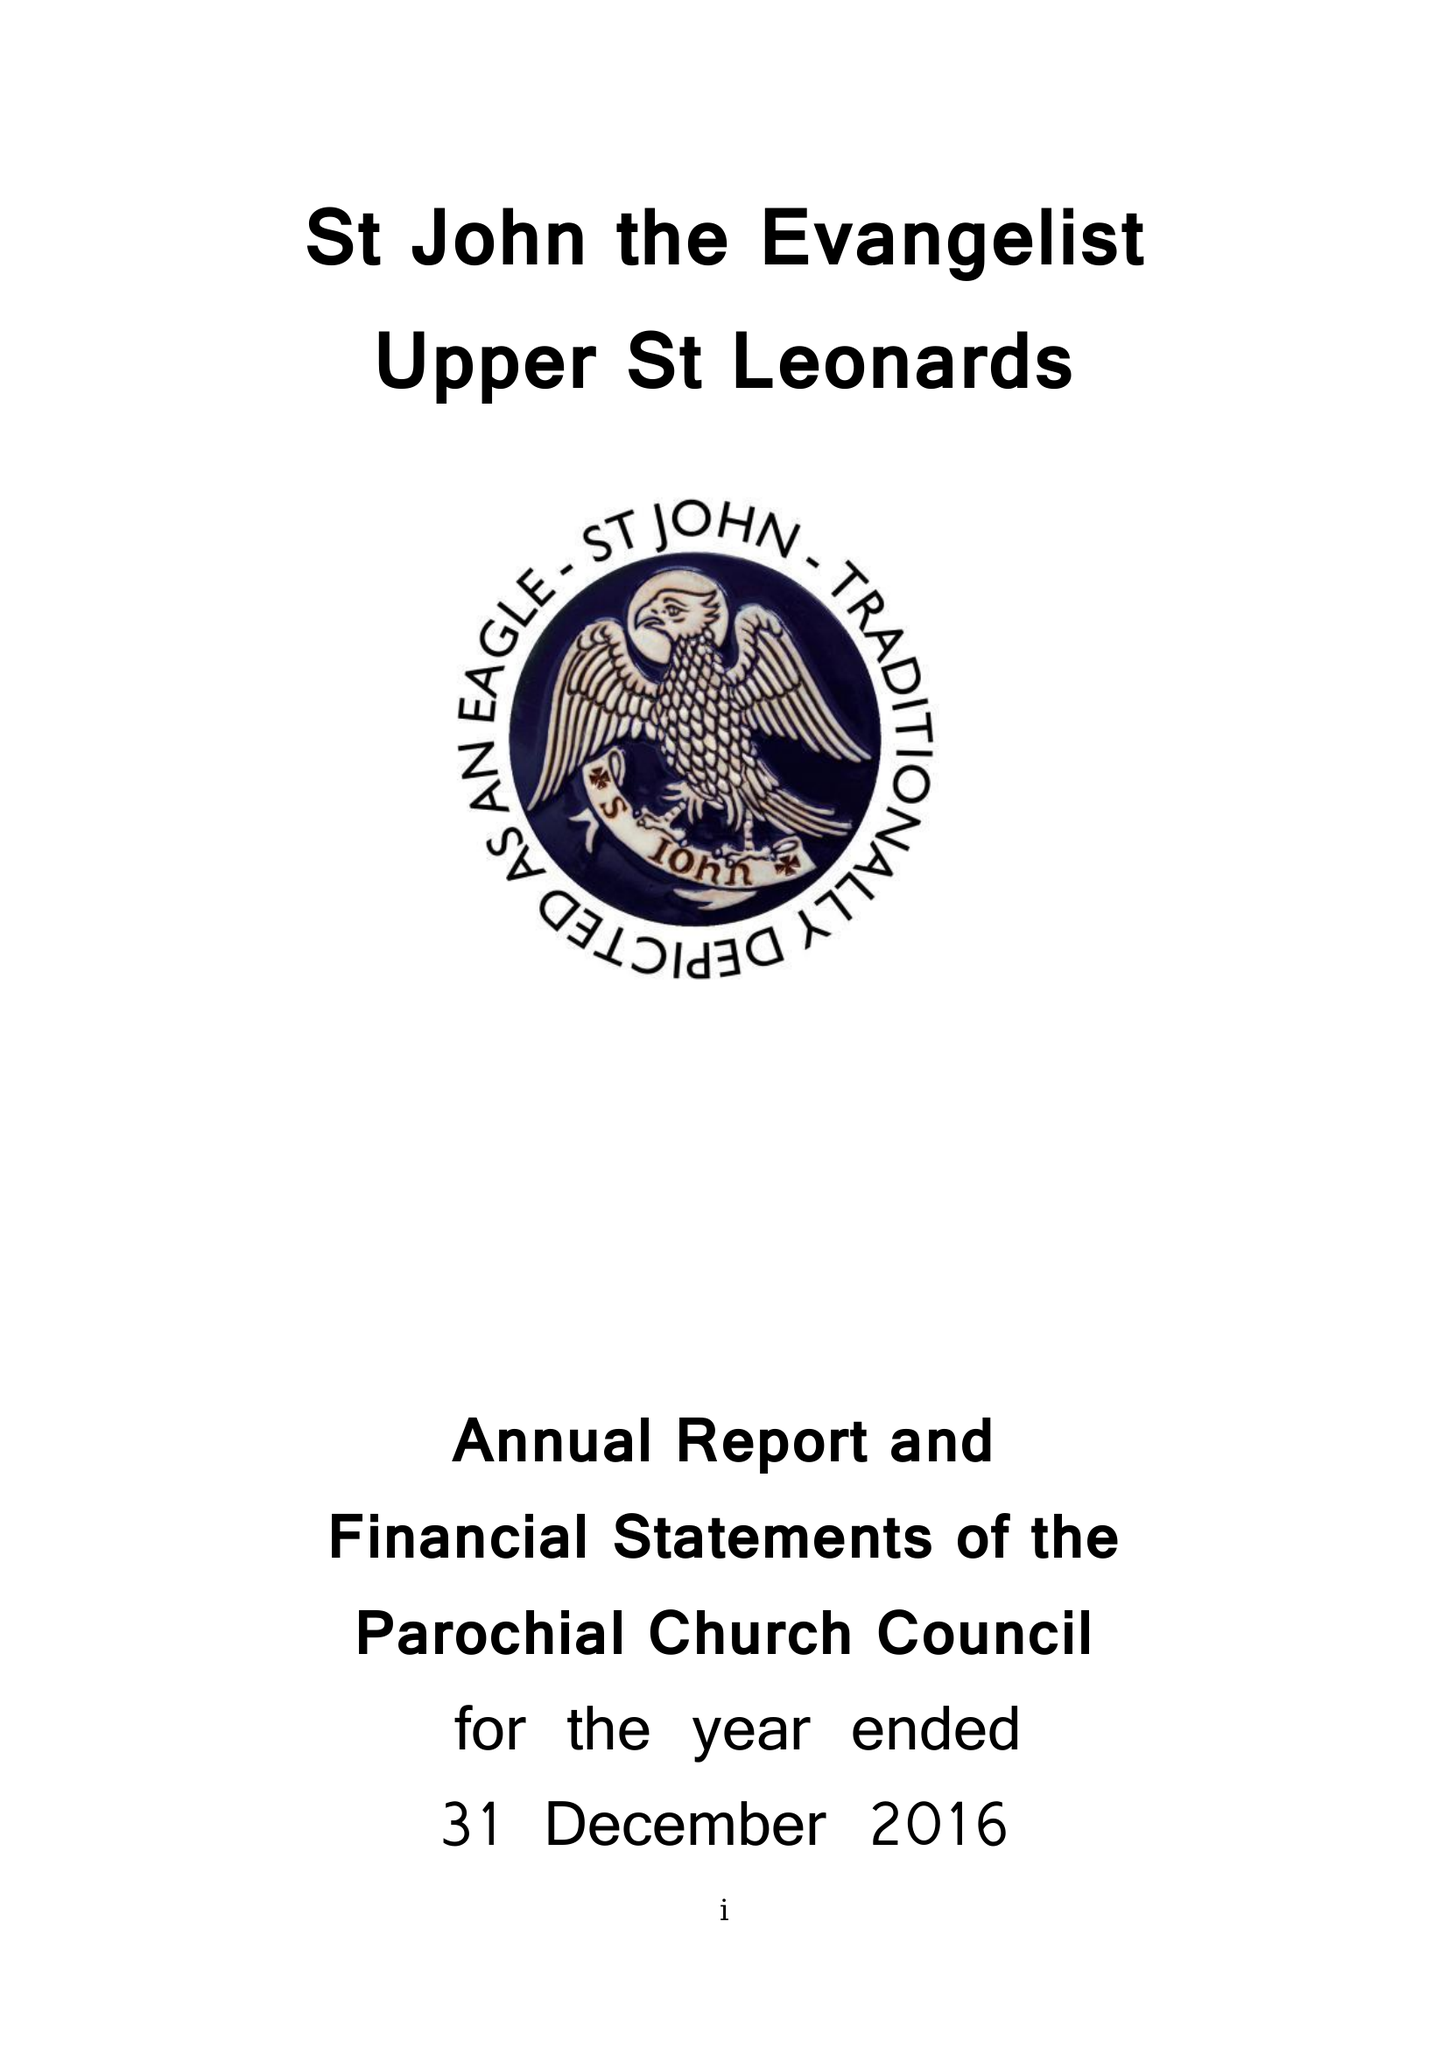What is the value for the spending_annually_in_british_pounds?
Answer the question using a single word or phrase. 130554.00 